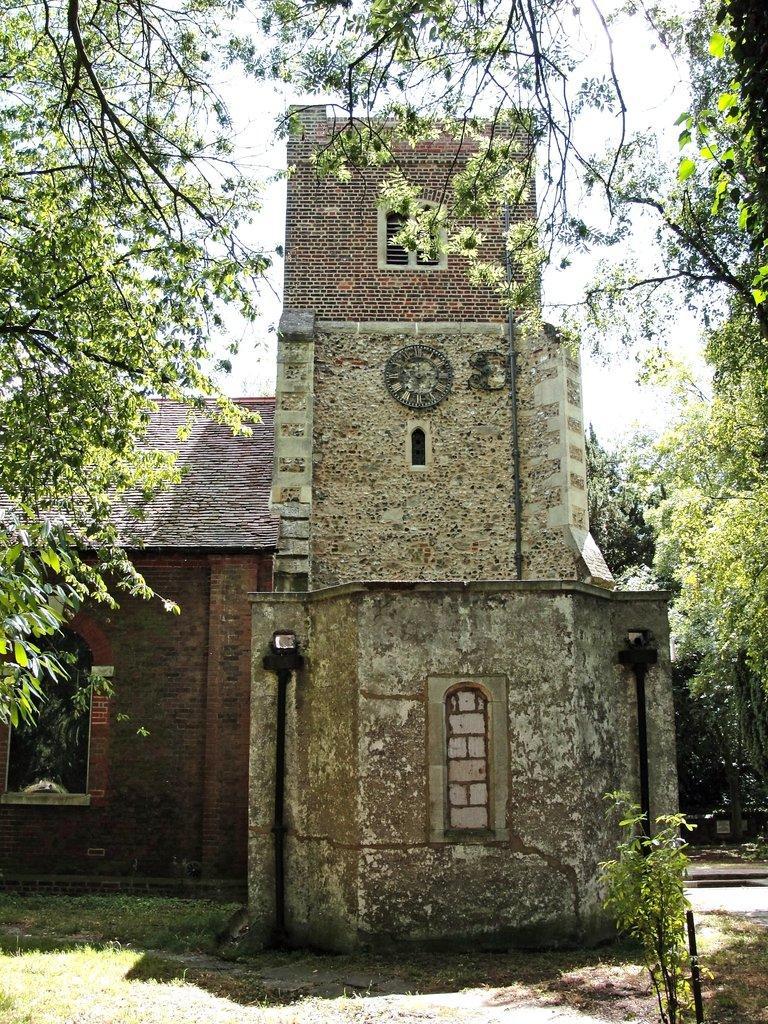Describe this image in one or two sentences. In the center of the image, we can see a building and there is a clock on the wall. In the background, there are trees, poles and plants. At the bottom, there is ground. 